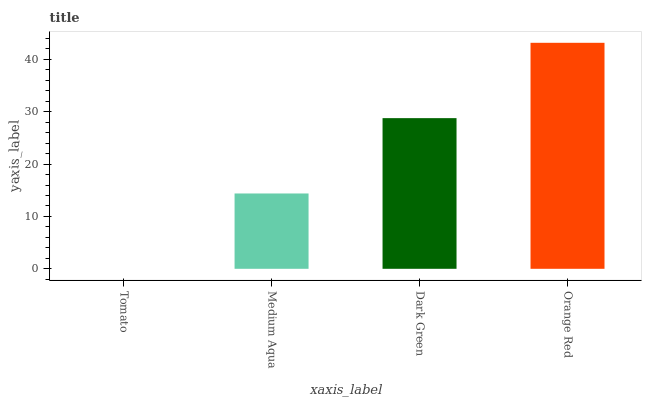Is Tomato the minimum?
Answer yes or no. Yes. Is Orange Red the maximum?
Answer yes or no. Yes. Is Medium Aqua the minimum?
Answer yes or no. No. Is Medium Aqua the maximum?
Answer yes or no. No. Is Medium Aqua greater than Tomato?
Answer yes or no. Yes. Is Tomato less than Medium Aqua?
Answer yes or no. Yes. Is Tomato greater than Medium Aqua?
Answer yes or no. No. Is Medium Aqua less than Tomato?
Answer yes or no. No. Is Dark Green the high median?
Answer yes or no. Yes. Is Medium Aqua the low median?
Answer yes or no. Yes. Is Orange Red the high median?
Answer yes or no. No. Is Tomato the low median?
Answer yes or no. No. 